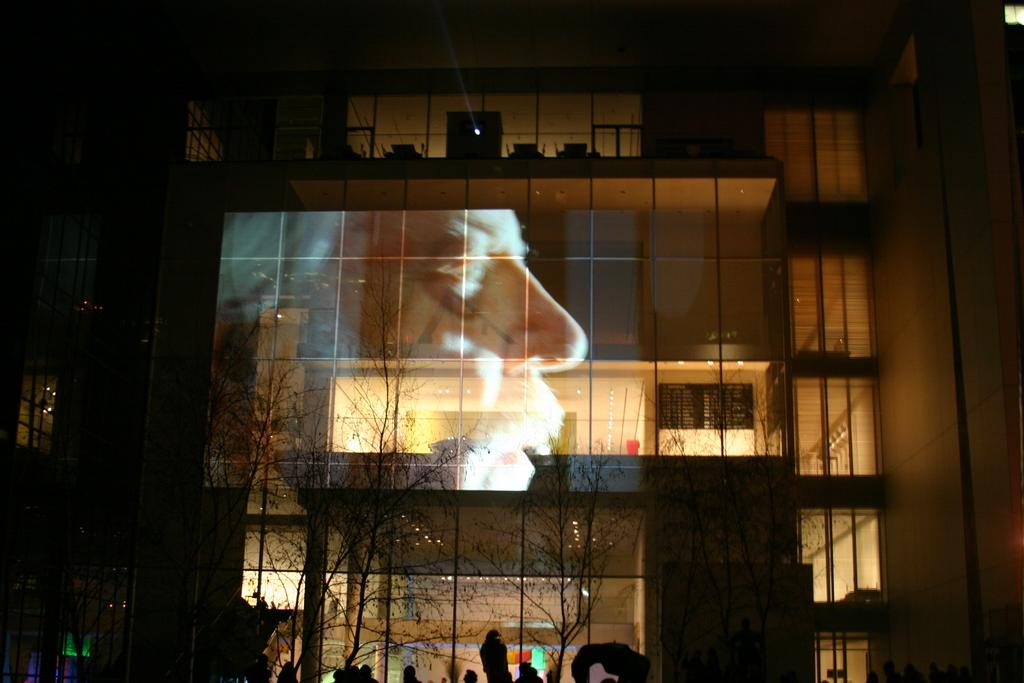What is the main structure in the image? There is a building in the image. Can you describe the people at the bottom of the image? There are many people at the bottom of the image. What type of vegetation is present in the image? There are few trees in the image. What unique feature can be seen on the building? There is a face of a person on the glasses of the building. What historical event is being commemorated by the spot on the building? There is no spot on the building in the image, and no historical event is being commemorated. What type of rod can be seen holding up the building? There are no rods visible in the image, and the building's structure is not described in the provided facts. 